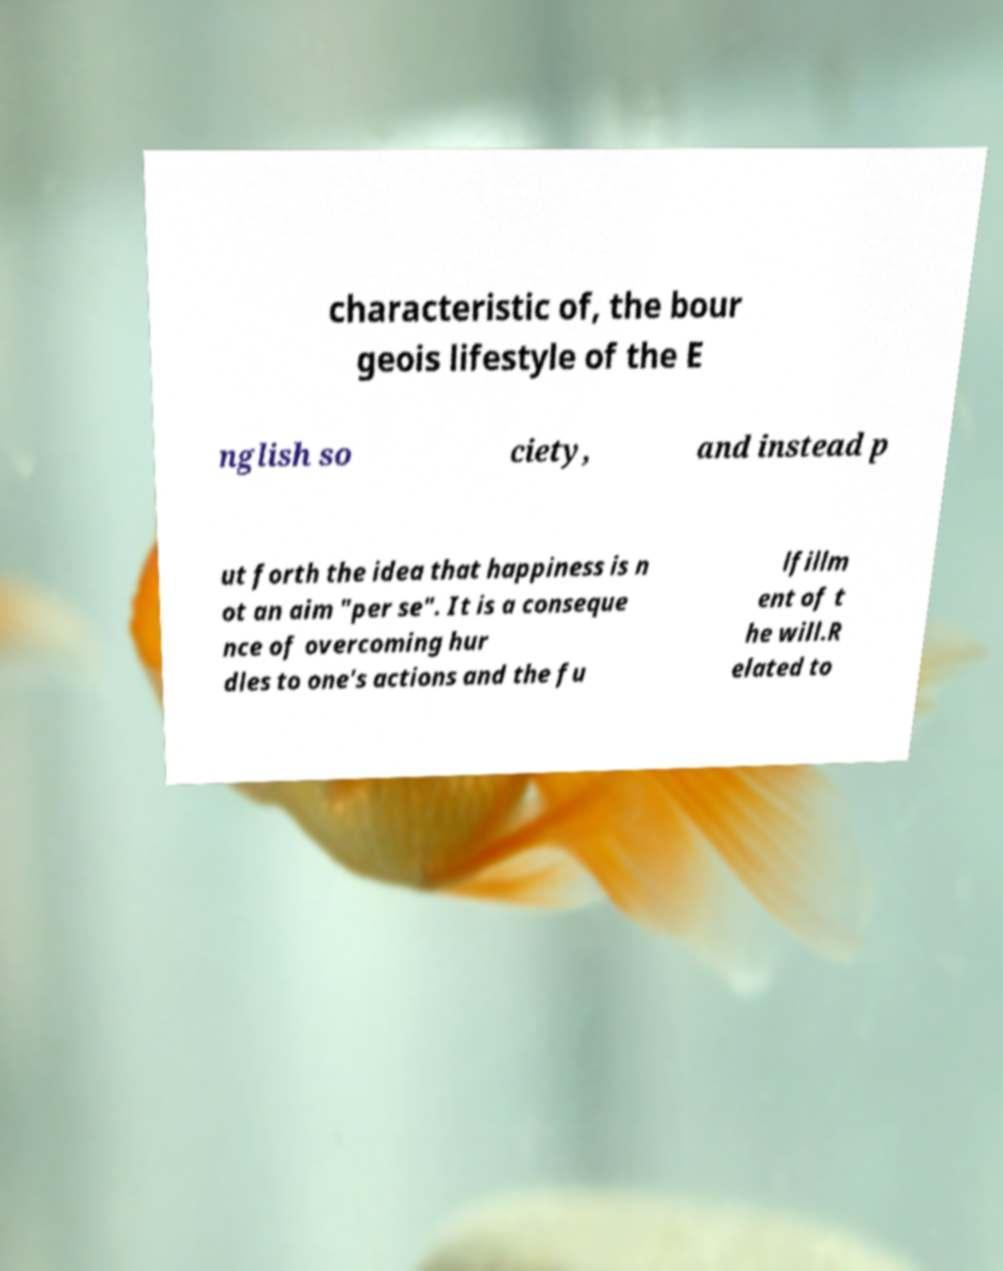Can you accurately transcribe the text from the provided image for me? characteristic of, the bour geois lifestyle of the E nglish so ciety, and instead p ut forth the idea that happiness is n ot an aim "per se". It is a conseque nce of overcoming hur dles to one's actions and the fu lfillm ent of t he will.R elated to 